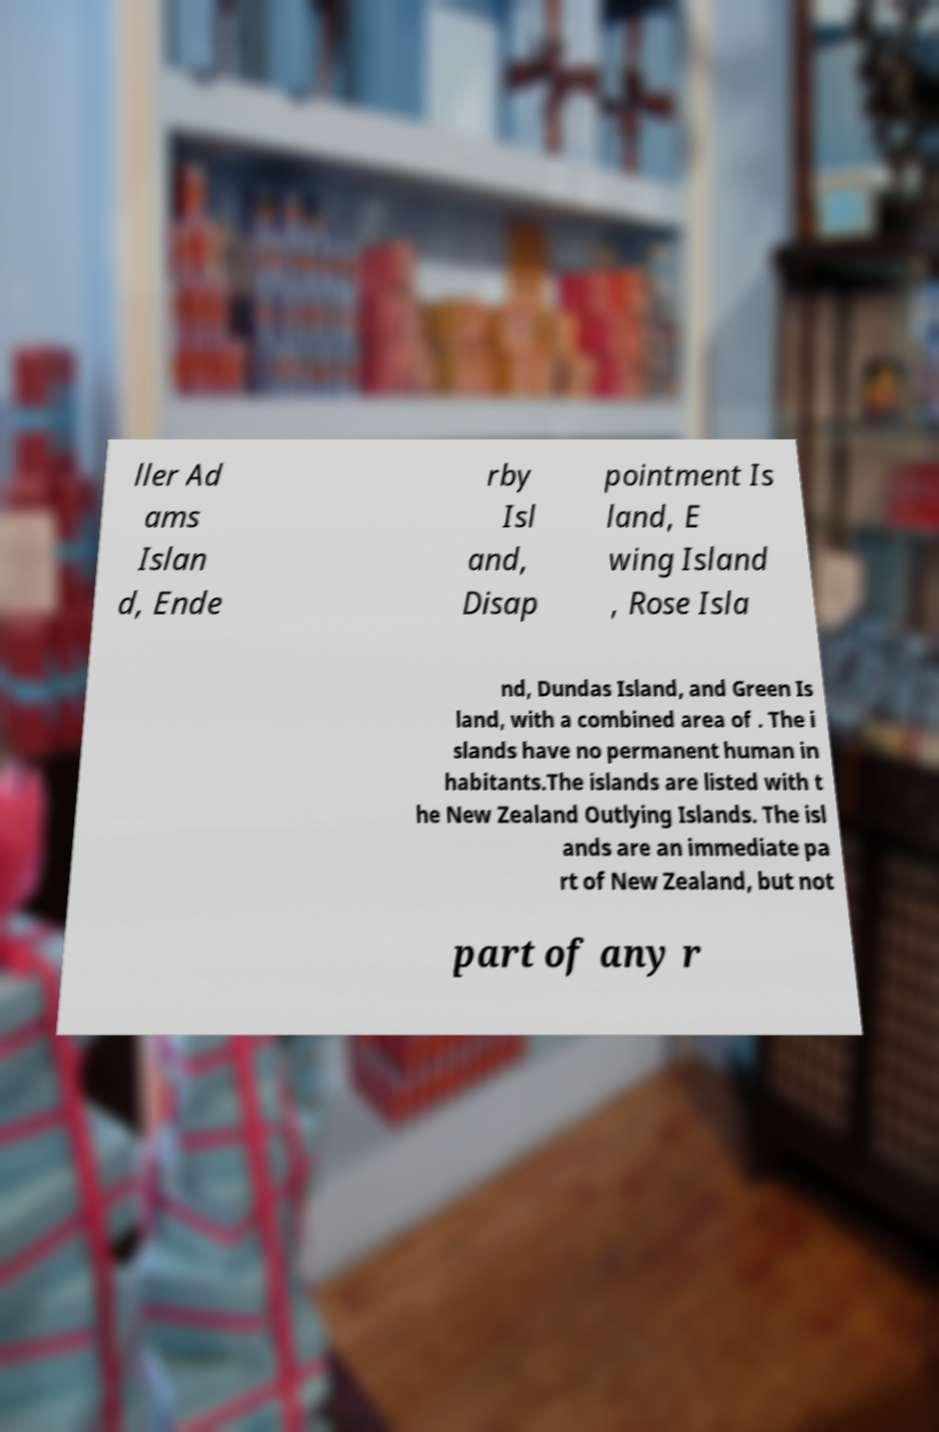Could you assist in decoding the text presented in this image and type it out clearly? ller Ad ams Islan d, Ende rby Isl and, Disap pointment Is land, E wing Island , Rose Isla nd, Dundas Island, and Green Is land, with a combined area of . The i slands have no permanent human in habitants.The islands are listed with t he New Zealand Outlying Islands. The isl ands are an immediate pa rt of New Zealand, but not part of any r 